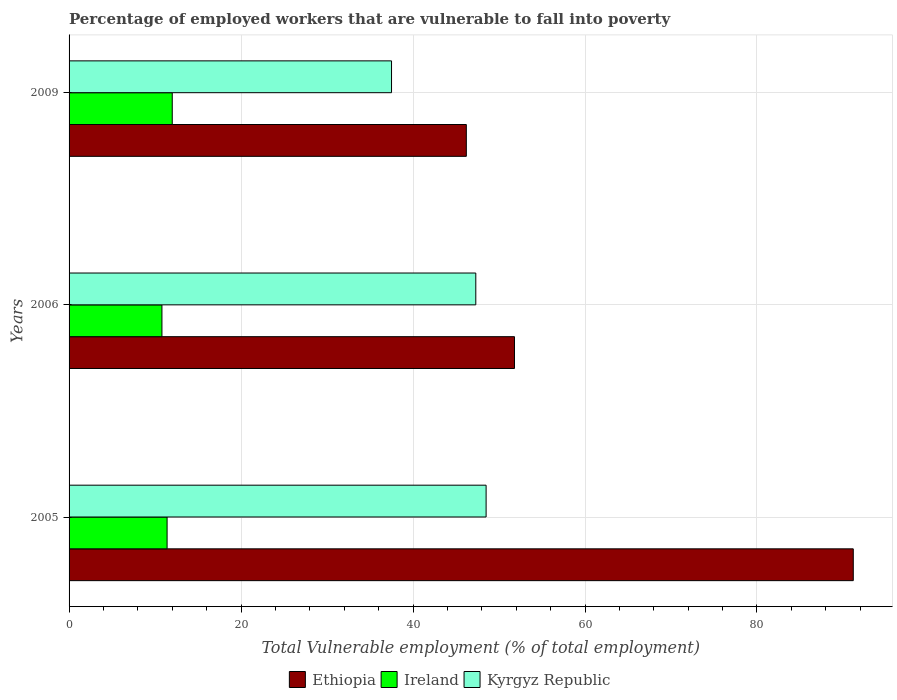How many different coloured bars are there?
Your answer should be compact. 3. How many groups of bars are there?
Give a very brief answer. 3. Are the number of bars on each tick of the Y-axis equal?
Ensure brevity in your answer.  Yes. How many bars are there on the 2nd tick from the bottom?
Your answer should be very brief. 3. What is the label of the 1st group of bars from the top?
Keep it short and to the point. 2009. In how many cases, is the number of bars for a given year not equal to the number of legend labels?
Offer a terse response. 0. What is the percentage of employed workers who are vulnerable to fall into poverty in Ethiopia in 2005?
Give a very brief answer. 91.2. Across all years, what is the maximum percentage of employed workers who are vulnerable to fall into poverty in Kyrgyz Republic?
Offer a very short reply. 48.5. Across all years, what is the minimum percentage of employed workers who are vulnerable to fall into poverty in Kyrgyz Republic?
Your answer should be very brief. 37.5. In which year was the percentage of employed workers who are vulnerable to fall into poverty in Ireland maximum?
Your answer should be compact. 2009. What is the total percentage of employed workers who are vulnerable to fall into poverty in Kyrgyz Republic in the graph?
Your answer should be very brief. 133.3. What is the difference between the percentage of employed workers who are vulnerable to fall into poverty in Ireland in 2005 and the percentage of employed workers who are vulnerable to fall into poverty in Ethiopia in 2009?
Your answer should be very brief. -34.8. What is the average percentage of employed workers who are vulnerable to fall into poverty in Ireland per year?
Ensure brevity in your answer.  11.4. In the year 2005, what is the difference between the percentage of employed workers who are vulnerable to fall into poverty in Ireland and percentage of employed workers who are vulnerable to fall into poverty in Kyrgyz Republic?
Keep it short and to the point. -37.1. In how many years, is the percentage of employed workers who are vulnerable to fall into poverty in Kyrgyz Republic greater than 88 %?
Keep it short and to the point. 0. What is the ratio of the percentage of employed workers who are vulnerable to fall into poverty in Ireland in 2005 to that in 2009?
Provide a short and direct response. 0.95. Is the percentage of employed workers who are vulnerable to fall into poverty in Ireland in 2005 less than that in 2009?
Your answer should be compact. Yes. What is the difference between the highest and the second highest percentage of employed workers who are vulnerable to fall into poverty in Ethiopia?
Your response must be concise. 39.4. What is the difference between the highest and the lowest percentage of employed workers who are vulnerable to fall into poverty in Kyrgyz Republic?
Give a very brief answer. 11. In how many years, is the percentage of employed workers who are vulnerable to fall into poverty in Ethiopia greater than the average percentage of employed workers who are vulnerable to fall into poverty in Ethiopia taken over all years?
Ensure brevity in your answer.  1. Is the sum of the percentage of employed workers who are vulnerable to fall into poverty in Ireland in 2005 and 2006 greater than the maximum percentage of employed workers who are vulnerable to fall into poverty in Ethiopia across all years?
Ensure brevity in your answer.  No. What does the 2nd bar from the top in 2006 represents?
Provide a succinct answer. Ireland. What does the 3rd bar from the bottom in 2006 represents?
Offer a terse response. Kyrgyz Republic. Are all the bars in the graph horizontal?
Offer a terse response. Yes. What is the difference between two consecutive major ticks on the X-axis?
Ensure brevity in your answer.  20. Are the values on the major ticks of X-axis written in scientific E-notation?
Offer a very short reply. No. Does the graph contain any zero values?
Offer a very short reply. No. How are the legend labels stacked?
Make the answer very short. Horizontal. What is the title of the graph?
Keep it short and to the point. Percentage of employed workers that are vulnerable to fall into poverty. Does "United Kingdom" appear as one of the legend labels in the graph?
Offer a very short reply. No. What is the label or title of the X-axis?
Your answer should be compact. Total Vulnerable employment (% of total employment). What is the label or title of the Y-axis?
Your response must be concise. Years. What is the Total Vulnerable employment (% of total employment) in Ethiopia in 2005?
Your response must be concise. 91.2. What is the Total Vulnerable employment (% of total employment) of Ireland in 2005?
Provide a short and direct response. 11.4. What is the Total Vulnerable employment (% of total employment) of Kyrgyz Republic in 2005?
Give a very brief answer. 48.5. What is the Total Vulnerable employment (% of total employment) in Ethiopia in 2006?
Offer a very short reply. 51.8. What is the Total Vulnerable employment (% of total employment) of Ireland in 2006?
Your answer should be very brief. 10.8. What is the Total Vulnerable employment (% of total employment) in Kyrgyz Republic in 2006?
Your answer should be compact. 47.3. What is the Total Vulnerable employment (% of total employment) of Ethiopia in 2009?
Ensure brevity in your answer.  46.2. What is the Total Vulnerable employment (% of total employment) of Kyrgyz Republic in 2009?
Make the answer very short. 37.5. Across all years, what is the maximum Total Vulnerable employment (% of total employment) in Ethiopia?
Your answer should be compact. 91.2. Across all years, what is the maximum Total Vulnerable employment (% of total employment) of Ireland?
Offer a terse response. 12. Across all years, what is the maximum Total Vulnerable employment (% of total employment) of Kyrgyz Republic?
Offer a very short reply. 48.5. Across all years, what is the minimum Total Vulnerable employment (% of total employment) of Ethiopia?
Your answer should be compact. 46.2. Across all years, what is the minimum Total Vulnerable employment (% of total employment) in Ireland?
Your answer should be very brief. 10.8. Across all years, what is the minimum Total Vulnerable employment (% of total employment) of Kyrgyz Republic?
Your response must be concise. 37.5. What is the total Total Vulnerable employment (% of total employment) of Ethiopia in the graph?
Offer a very short reply. 189.2. What is the total Total Vulnerable employment (% of total employment) in Ireland in the graph?
Offer a terse response. 34.2. What is the total Total Vulnerable employment (% of total employment) of Kyrgyz Republic in the graph?
Offer a terse response. 133.3. What is the difference between the Total Vulnerable employment (% of total employment) in Ethiopia in 2005 and that in 2006?
Ensure brevity in your answer.  39.4. What is the difference between the Total Vulnerable employment (% of total employment) in Kyrgyz Republic in 2005 and that in 2006?
Your answer should be compact. 1.2. What is the difference between the Total Vulnerable employment (% of total employment) of Ethiopia in 2005 and that in 2009?
Your answer should be very brief. 45. What is the difference between the Total Vulnerable employment (% of total employment) of Ireland in 2005 and that in 2009?
Provide a succinct answer. -0.6. What is the difference between the Total Vulnerable employment (% of total employment) of Kyrgyz Republic in 2005 and that in 2009?
Make the answer very short. 11. What is the difference between the Total Vulnerable employment (% of total employment) of Ethiopia in 2006 and that in 2009?
Your answer should be very brief. 5.6. What is the difference between the Total Vulnerable employment (% of total employment) in Kyrgyz Republic in 2006 and that in 2009?
Offer a very short reply. 9.8. What is the difference between the Total Vulnerable employment (% of total employment) of Ethiopia in 2005 and the Total Vulnerable employment (% of total employment) of Ireland in 2006?
Provide a succinct answer. 80.4. What is the difference between the Total Vulnerable employment (% of total employment) of Ethiopia in 2005 and the Total Vulnerable employment (% of total employment) of Kyrgyz Republic in 2006?
Give a very brief answer. 43.9. What is the difference between the Total Vulnerable employment (% of total employment) of Ireland in 2005 and the Total Vulnerable employment (% of total employment) of Kyrgyz Republic in 2006?
Your answer should be very brief. -35.9. What is the difference between the Total Vulnerable employment (% of total employment) of Ethiopia in 2005 and the Total Vulnerable employment (% of total employment) of Ireland in 2009?
Give a very brief answer. 79.2. What is the difference between the Total Vulnerable employment (% of total employment) in Ethiopia in 2005 and the Total Vulnerable employment (% of total employment) in Kyrgyz Republic in 2009?
Ensure brevity in your answer.  53.7. What is the difference between the Total Vulnerable employment (% of total employment) of Ireland in 2005 and the Total Vulnerable employment (% of total employment) of Kyrgyz Republic in 2009?
Provide a succinct answer. -26.1. What is the difference between the Total Vulnerable employment (% of total employment) in Ethiopia in 2006 and the Total Vulnerable employment (% of total employment) in Ireland in 2009?
Give a very brief answer. 39.8. What is the difference between the Total Vulnerable employment (% of total employment) of Ethiopia in 2006 and the Total Vulnerable employment (% of total employment) of Kyrgyz Republic in 2009?
Your response must be concise. 14.3. What is the difference between the Total Vulnerable employment (% of total employment) of Ireland in 2006 and the Total Vulnerable employment (% of total employment) of Kyrgyz Republic in 2009?
Your response must be concise. -26.7. What is the average Total Vulnerable employment (% of total employment) of Ethiopia per year?
Your answer should be very brief. 63.07. What is the average Total Vulnerable employment (% of total employment) of Kyrgyz Republic per year?
Keep it short and to the point. 44.43. In the year 2005, what is the difference between the Total Vulnerable employment (% of total employment) of Ethiopia and Total Vulnerable employment (% of total employment) of Ireland?
Keep it short and to the point. 79.8. In the year 2005, what is the difference between the Total Vulnerable employment (% of total employment) of Ethiopia and Total Vulnerable employment (% of total employment) of Kyrgyz Republic?
Provide a succinct answer. 42.7. In the year 2005, what is the difference between the Total Vulnerable employment (% of total employment) of Ireland and Total Vulnerable employment (% of total employment) of Kyrgyz Republic?
Your answer should be compact. -37.1. In the year 2006, what is the difference between the Total Vulnerable employment (% of total employment) in Ethiopia and Total Vulnerable employment (% of total employment) in Kyrgyz Republic?
Offer a terse response. 4.5. In the year 2006, what is the difference between the Total Vulnerable employment (% of total employment) of Ireland and Total Vulnerable employment (% of total employment) of Kyrgyz Republic?
Make the answer very short. -36.5. In the year 2009, what is the difference between the Total Vulnerable employment (% of total employment) of Ethiopia and Total Vulnerable employment (% of total employment) of Ireland?
Your answer should be compact. 34.2. In the year 2009, what is the difference between the Total Vulnerable employment (% of total employment) in Ethiopia and Total Vulnerable employment (% of total employment) in Kyrgyz Republic?
Offer a terse response. 8.7. In the year 2009, what is the difference between the Total Vulnerable employment (% of total employment) of Ireland and Total Vulnerable employment (% of total employment) of Kyrgyz Republic?
Offer a very short reply. -25.5. What is the ratio of the Total Vulnerable employment (% of total employment) of Ethiopia in 2005 to that in 2006?
Provide a succinct answer. 1.76. What is the ratio of the Total Vulnerable employment (% of total employment) in Ireland in 2005 to that in 2006?
Make the answer very short. 1.06. What is the ratio of the Total Vulnerable employment (% of total employment) of Kyrgyz Republic in 2005 to that in 2006?
Your answer should be compact. 1.03. What is the ratio of the Total Vulnerable employment (% of total employment) of Ethiopia in 2005 to that in 2009?
Provide a succinct answer. 1.97. What is the ratio of the Total Vulnerable employment (% of total employment) of Kyrgyz Republic in 2005 to that in 2009?
Provide a succinct answer. 1.29. What is the ratio of the Total Vulnerable employment (% of total employment) of Ethiopia in 2006 to that in 2009?
Your response must be concise. 1.12. What is the ratio of the Total Vulnerable employment (% of total employment) of Ireland in 2006 to that in 2009?
Offer a very short reply. 0.9. What is the ratio of the Total Vulnerable employment (% of total employment) of Kyrgyz Republic in 2006 to that in 2009?
Offer a very short reply. 1.26. What is the difference between the highest and the second highest Total Vulnerable employment (% of total employment) of Ethiopia?
Offer a very short reply. 39.4. What is the difference between the highest and the second highest Total Vulnerable employment (% of total employment) in Ireland?
Make the answer very short. 0.6. What is the difference between the highest and the second highest Total Vulnerable employment (% of total employment) of Kyrgyz Republic?
Your answer should be very brief. 1.2. What is the difference between the highest and the lowest Total Vulnerable employment (% of total employment) of Ireland?
Your answer should be very brief. 1.2. 